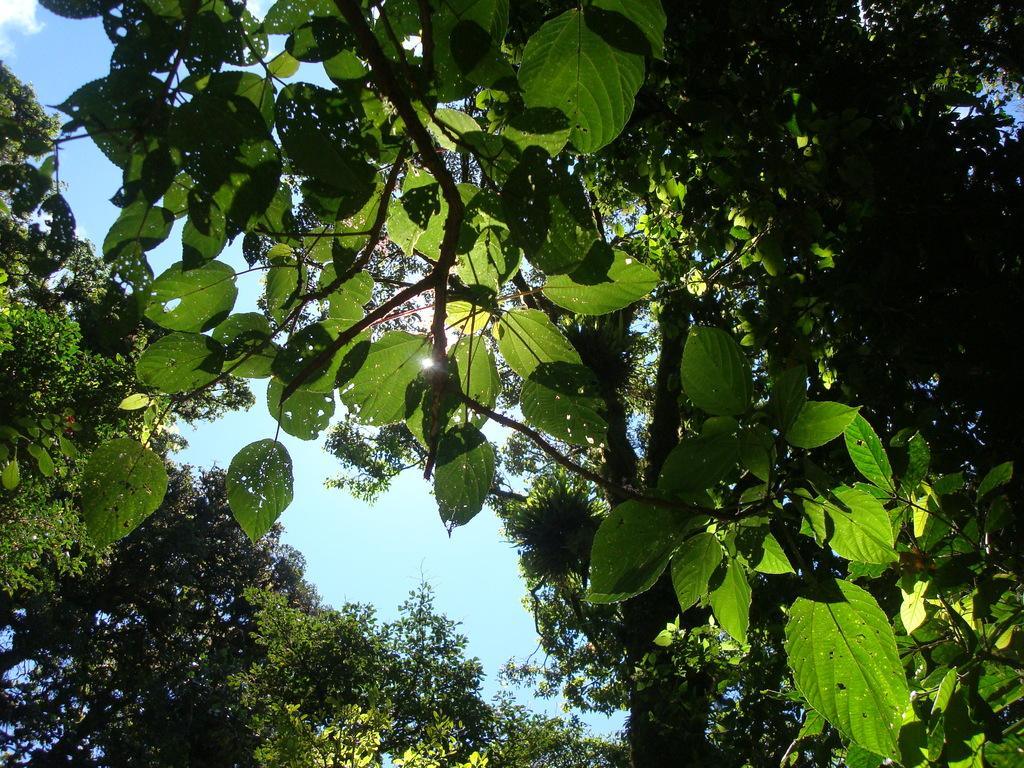What type of vegetation can be seen in the image? There are trees in the image. What color is the sky in the image? The sky is blue in the image. What brand of toothpaste is visible in the image? There is no toothpaste present in the image. Can you see any tigers in the image? There are no tigers visible in the image; only trees and the blue sky are present. 